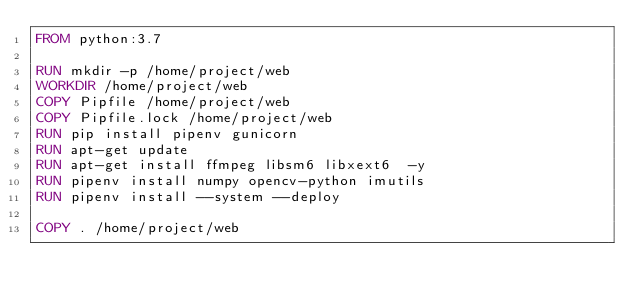Convert code to text. <code><loc_0><loc_0><loc_500><loc_500><_Dockerfile_>FROM python:3.7

RUN mkdir -p /home/project/web
WORKDIR /home/project/web
COPY Pipfile /home/project/web
COPY Pipfile.lock /home/project/web
RUN pip install pipenv gunicorn
RUN apt-get update
RUN apt-get install ffmpeg libsm6 libxext6  -y
RUN pipenv install numpy opencv-python imutils
RUN pipenv install --system --deploy

COPY . /home/project/web
</code> 